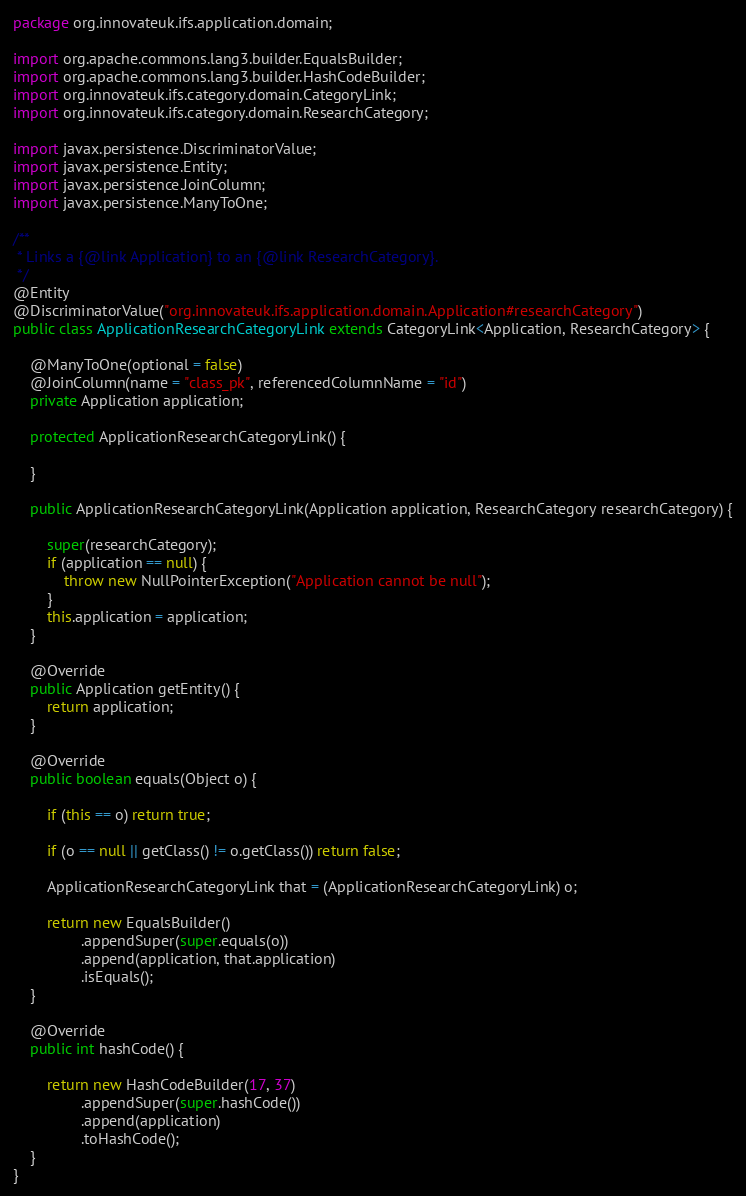<code> <loc_0><loc_0><loc_500><loc_500><_Java_>package org.innovateuk.ifs.application.domain;

import org.apache.commons.lang3.builder.EqualsBuilder;
import org.apache.commons.lang3.builder.HashCodeBuilder;
import org.innovateuk.ifs.category.domain.CategoryLink;
import org.innovateuk.ifs.category.domain.ResearchCategory;

import javax.persistence.DiscriminatorValue;
import javax.persistence.Entity;
import javax.persistence.JoinColumn;
import javax.persistence.ManyToOne;

/**
 * Links a {@link Application} to an {@link ResearchCategory}.
 */
@Entity
@DiscriminatorValue("org.innovateuk.ifs.application.domain.Application#researchCategory")
public class ApplicationResearchCategoryLink extends CategoryLink<Application, ResearchCategory> {

    @ManyToOne(optional = false)
    @JoinColumn(name = "class_pk", referencedColumnName = "id")
    private Application application;

    protected ApplicationResearchCategoryLink() {

    }

    public ApplicationResearchCategoryLink(Application application, ResearchCategory researchCategory) {

        super(researchCategory);
        if (application == null) {
            throw new NullPointerException("Application cannot be null");
        }
        this.application = application;
    }

    @Override
    public Application getEntity() {
        return application;
    }

    @Override
    public boolean equals(Object o) {

        if (this == o) return true;

        if (o == null || getClass() != o.getClass()) return false;

        ApplicationResearchCategoryLink that = (ApplicationResearchCategoryLink) o;

        return new EqualsBuilder()
                .appendSuper(super.equals(o))
                .append(application, that.application)
                .isEquals();
    }

    @Override
    public int hashCode() {

        return new HashCodeBuilder(17, 37)
                .appendSuper(super.hashCode())
                .append(application)
                .toHashCode();
    }
}</code> 